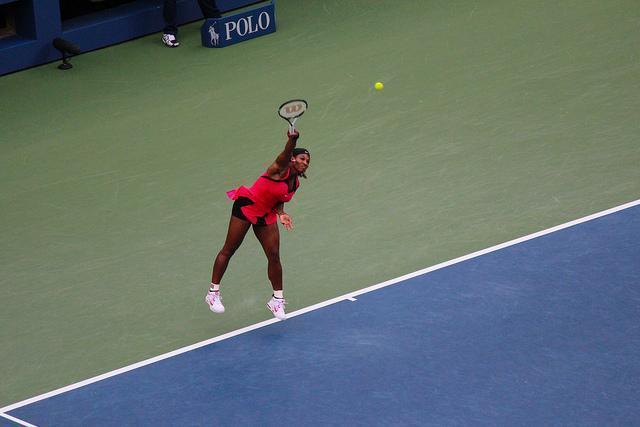How many bears are present?
Give a very brief answer. 0. 